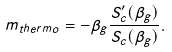Convert formula to latex. <formula><loc_0><loc_0><loc_500><loc_500>m _ { t h e r m o } = - \beta _ { g } \frac { S _ { c } ^ { \prime } ( \beta _ { g } ) } { S _ { c } ( \beta _ { g } ) } .</formula> 